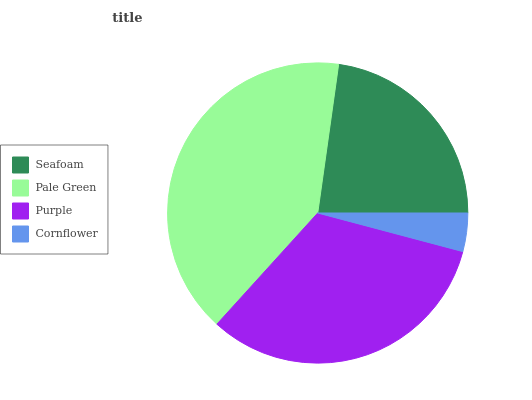Is Cornflower the minimum?
Answer yes or no. Yes. Is Pale Green the maximum?
Answer yes or no. Yes. Is Purple the minimum?
Answer yes or no. No. Is Purple the maximum?
Answer yes or no. No. Is Pale Green greater than Purple?
Answer yes or no. Yes. Is Purple less than Pale Green?
Answer yes or no. Yes. Is Purple greater than Pale Green?
Answer yes or no. No. Is Pale Green less than Purple?
Answer yes or no. No. Is Purple the high median?
Answer yes or no. Yes. Is Seafoam the low median?
Answer yes or no. Yes. Is Pale Green the high median?
Answer yes or no. No. Is Purple the low median?
Answer yes or no. No. 